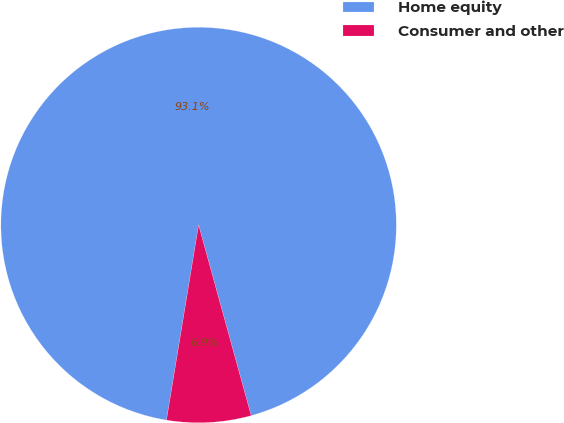<chart> <loc_0><loc_0><loc_500><loc_500><pie_chart><fcel>Home equity<fcel>Consumer and other<nl><fcel>93.12%<fcel>6.88%<nl></chart> 